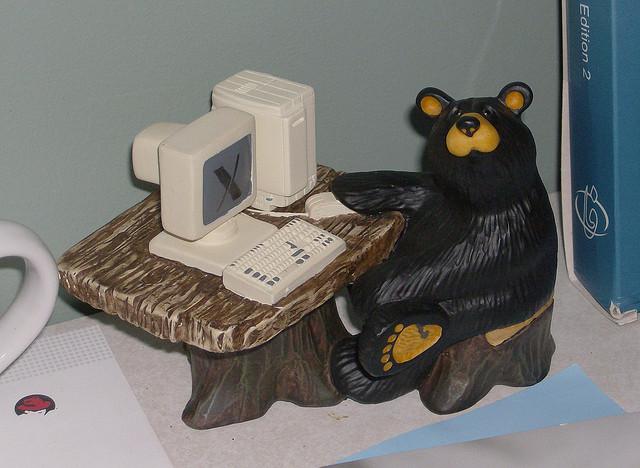What color is the bear?
Keep it brief. Black. Do you see a computer in the picture?
Keep it brief. Yes. Is the board wooden?
Give a very brief answer. Yes. Is this a vegetarian dish?
Concise answer only. No. What is the bear doing in the photo?
Answer briefly. Using computer. Are the objects fixed to the display?
Write a very short answer. No. What type of animal is this?
Short answer required. Bear. Where would this figurine be appropriate?
Keep it brief. Office. How many bears are here?
Be succinct. 1. 